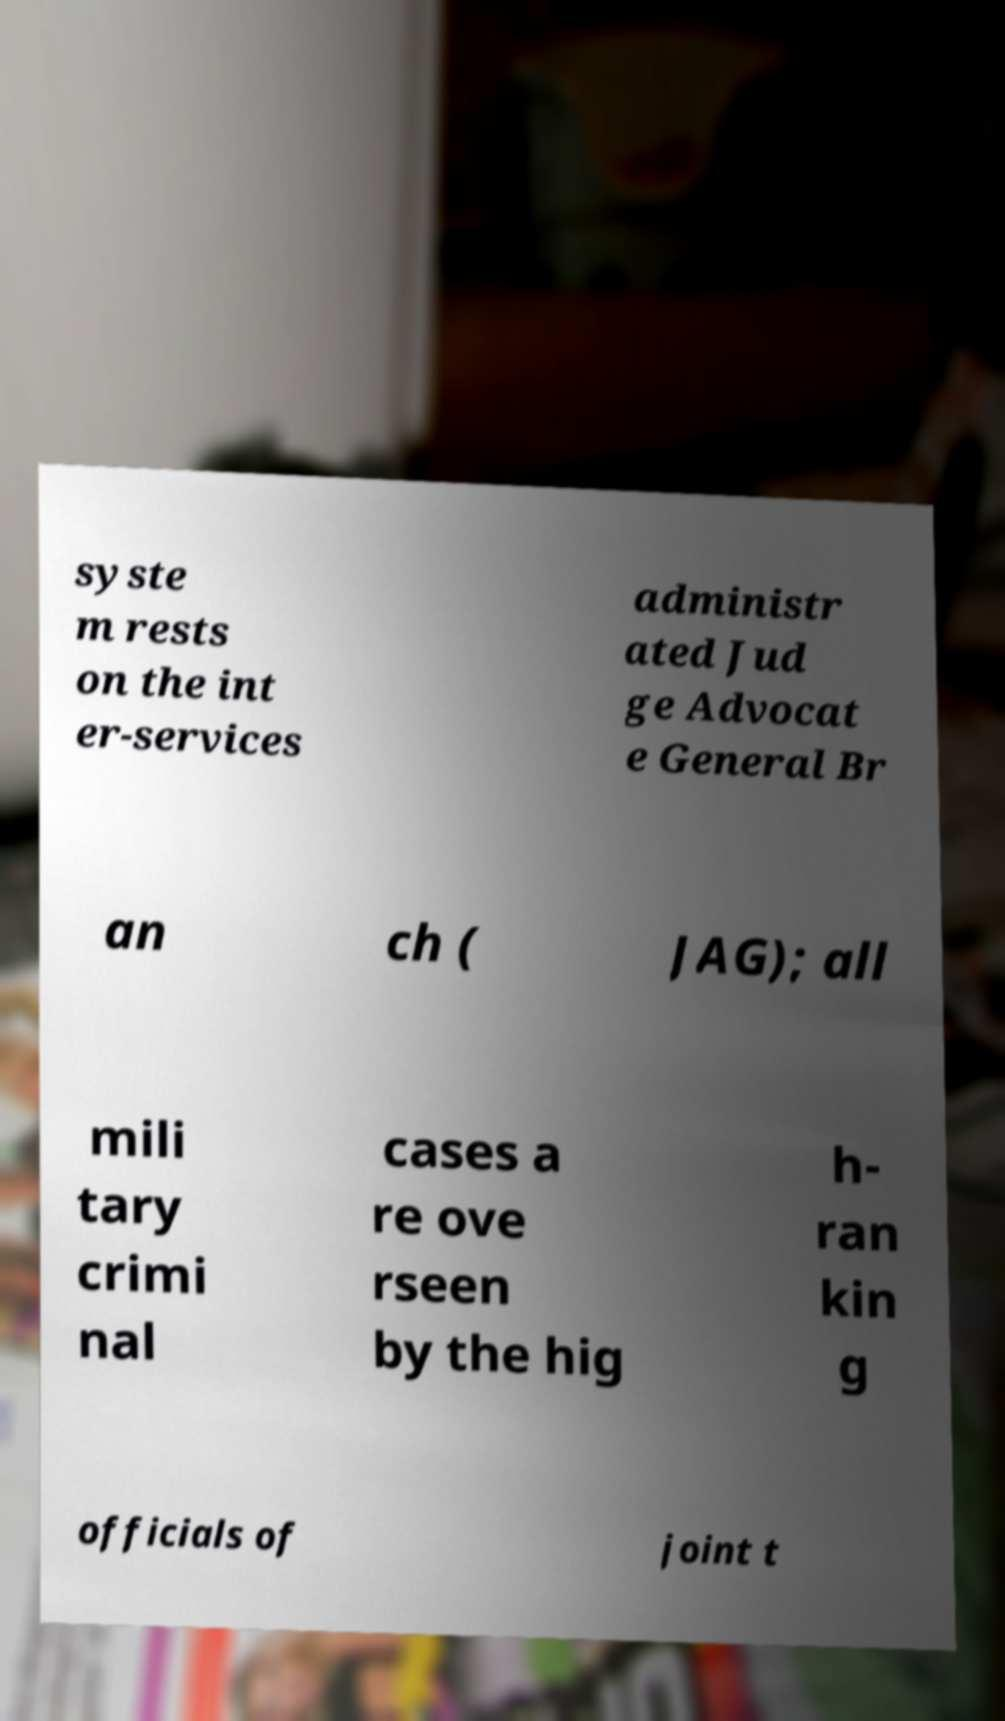I need the written content from this picture converted into text. Can you do that? syste m rests on the int er-services administr ated Jud ge Advocat e General Br an ch ( JAG); all mili tary crimi nal cases a re ove rseen by the hig h- ran kin g officials of joint t 